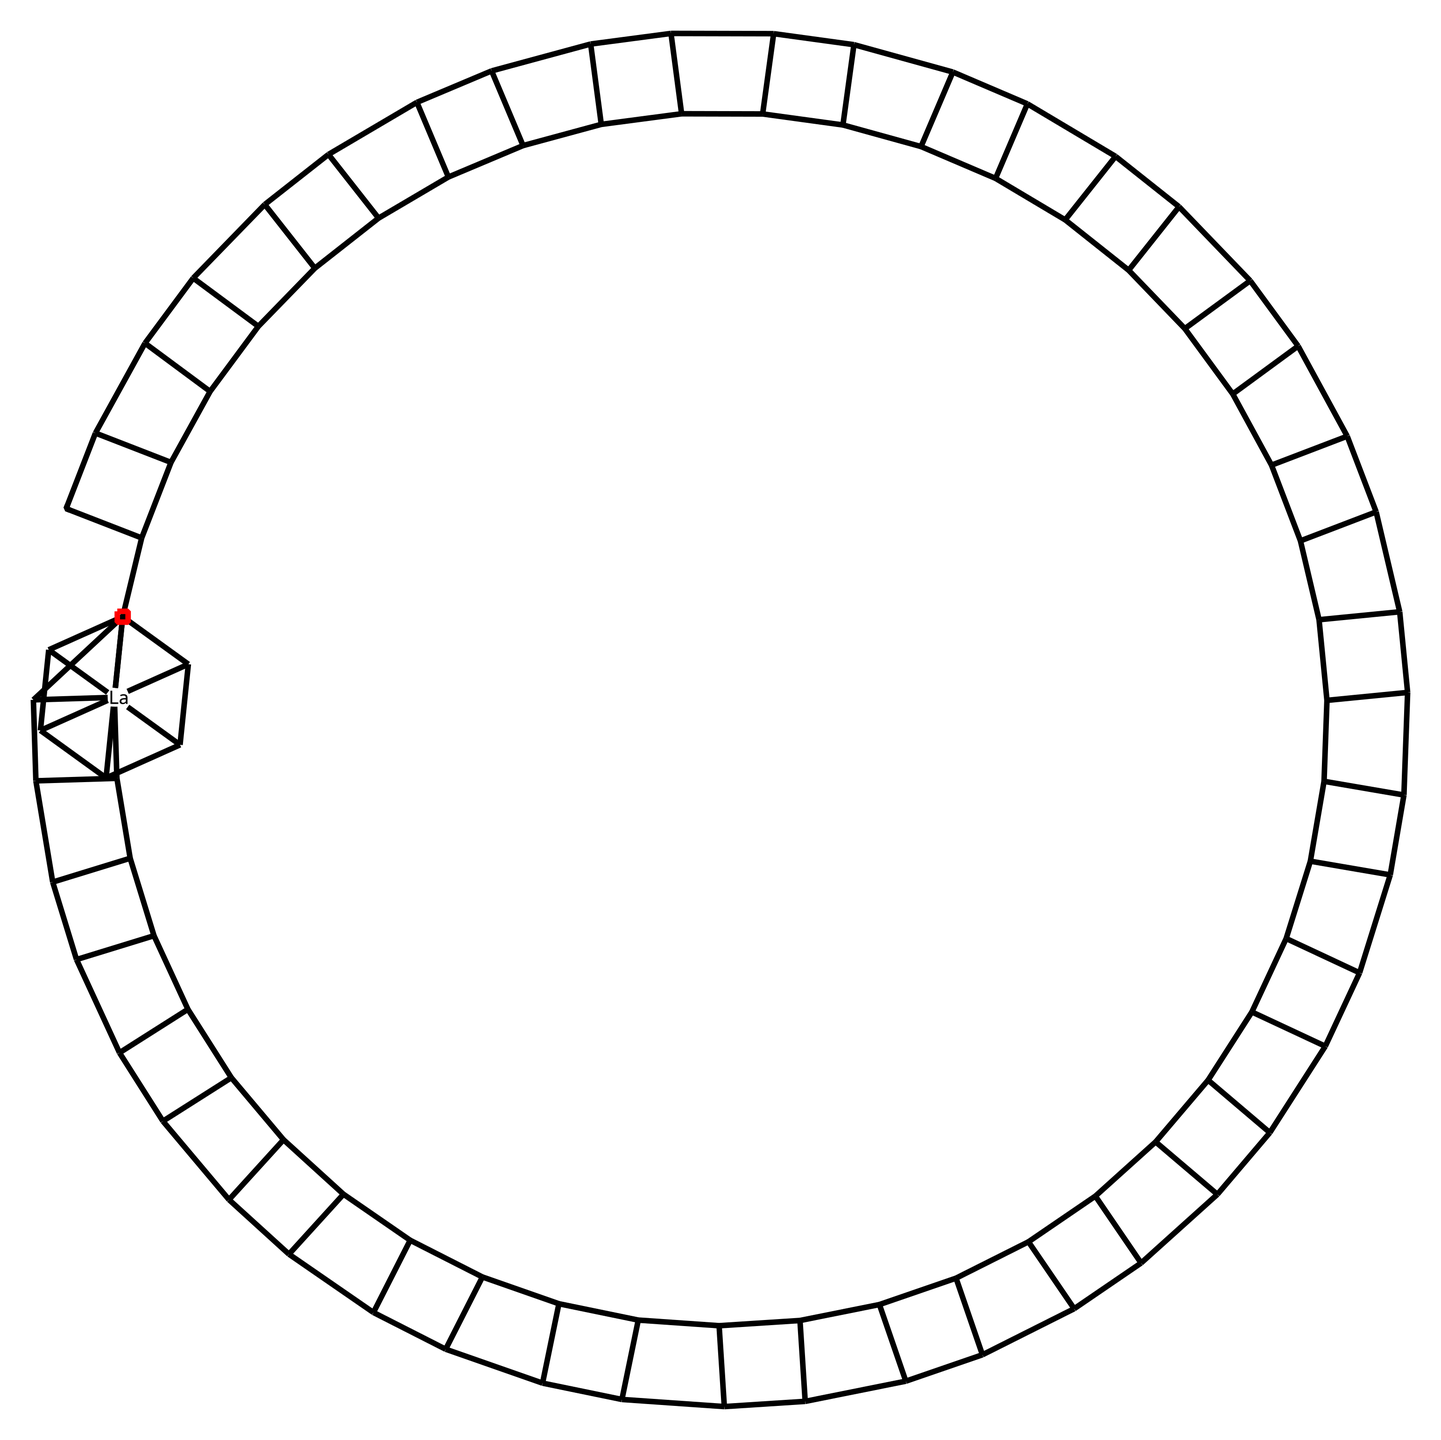What is the central atom in this endohedral fulleride? The chemical structure indicates the presence of a lanthanide atom, specifically lanthanum, denoted by the symbol [La@] which is located at the center of the fullerene cage.
Answer: lanthanum How many carbon atoms are in the fullerene structure? By analyzing the structure, we can observe that there are a total of 60 carbon atoms making up the fullerene framework, which is typical for a fullerene.
Answer: 60 What type of chemical bonding is primarily present in the fullerene structure? The primary bonding in fullerene structures is covalent. When examining the connections between the carbon atoms in the SMILES notation, it indicates a network of covalent bonds holding the structure together.
Answer: covalent What is the unique feature of endohedral fullerides compared to regular fullerenes? Endohedral fullerides contain trapped atoms or molecules within the carbon cage, which are indicated by the central [La@]. This distinguishes them from regular fullerenes, which do not contain any encapsulated species.
Answer: trapped atoms What kind of applications can be associated with endohedral fullerides like this one? Endohedral fullerides have potential applications in nanotechnology, drug delivery, and materials science due to their unique properties imparted by the encapsulated atoms, such as enhanced electronic or magnetic properties.
Answer: nanotechnology How does the presence of the lanthanum atom influence the properties of this fulleride? The inclusion of lanthanum can modify the electronic properties of the fullerene cage, affecting characteristics such as conductivity and magnetic behavior. The lanthanum atom introduces additional electronic states within the structure, which can be beneficial for various applications.
Answer: modifies electronic properties 